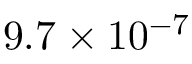Convert formula to latex. <formula><loc_0><loc_0><loc_500><loc_500>9 . 7 \times 1 0 ^ { - 7 }</formula> 